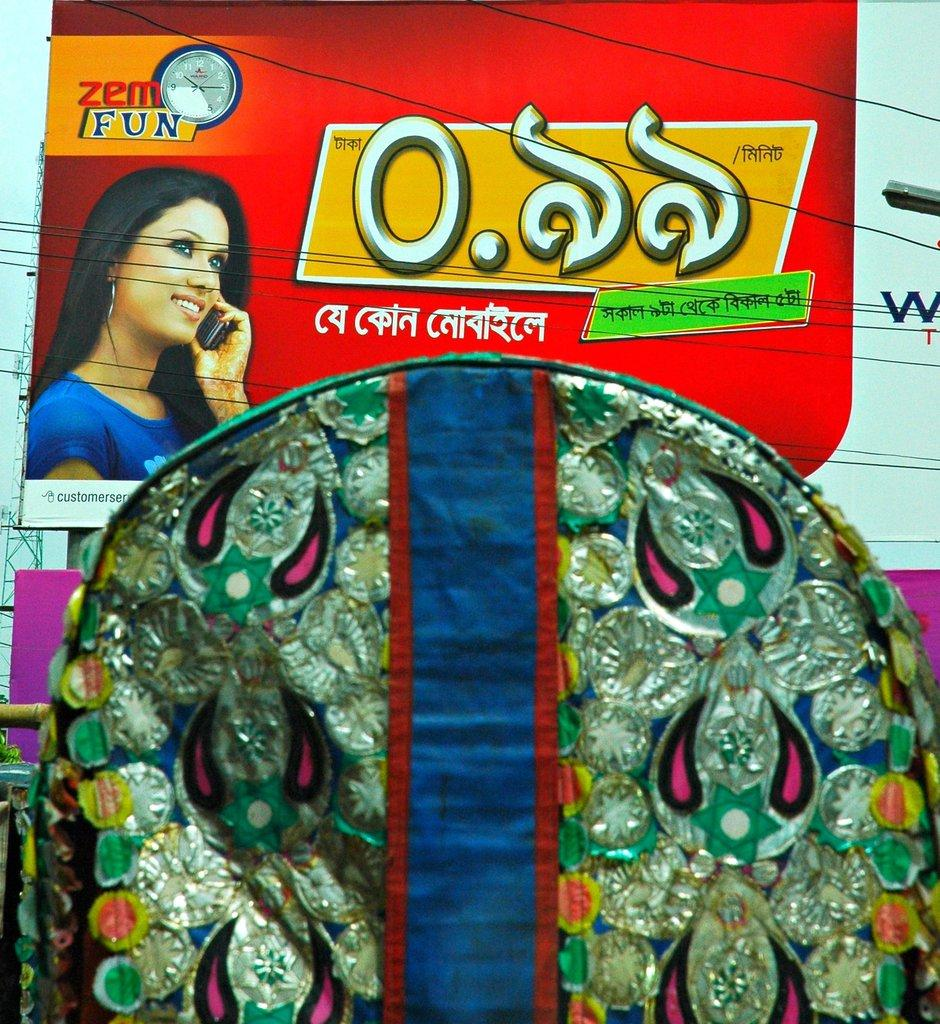What is the main object in the image? There is an advertisement board in the image. Who is present in the image? A woman is present in the image. What is the woman doing in the image? The woman is talking on a mobile phone. What is the woman wearing in the image? The woman is wearing a blue t-shirt. What type of creature is depicted on the stamp in the image? There is no stamp present in the image, so it is not possible to answer that question. 